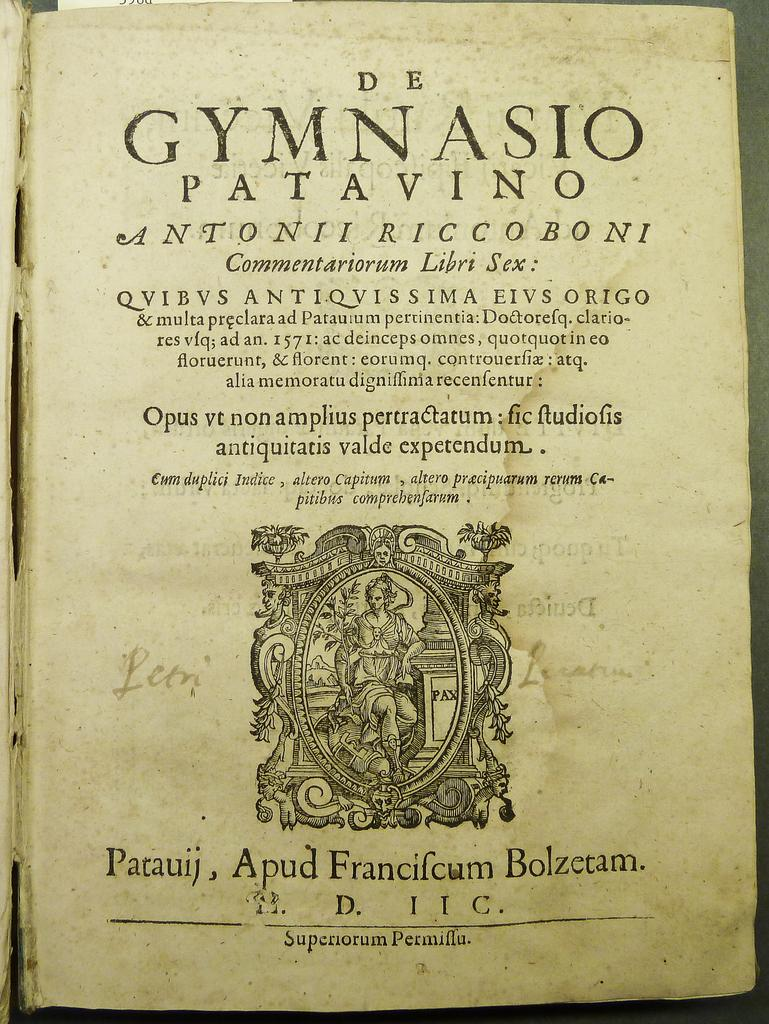<image>
Present a compact description of the photo's key features. An old book cover with a title and text written in latin. 